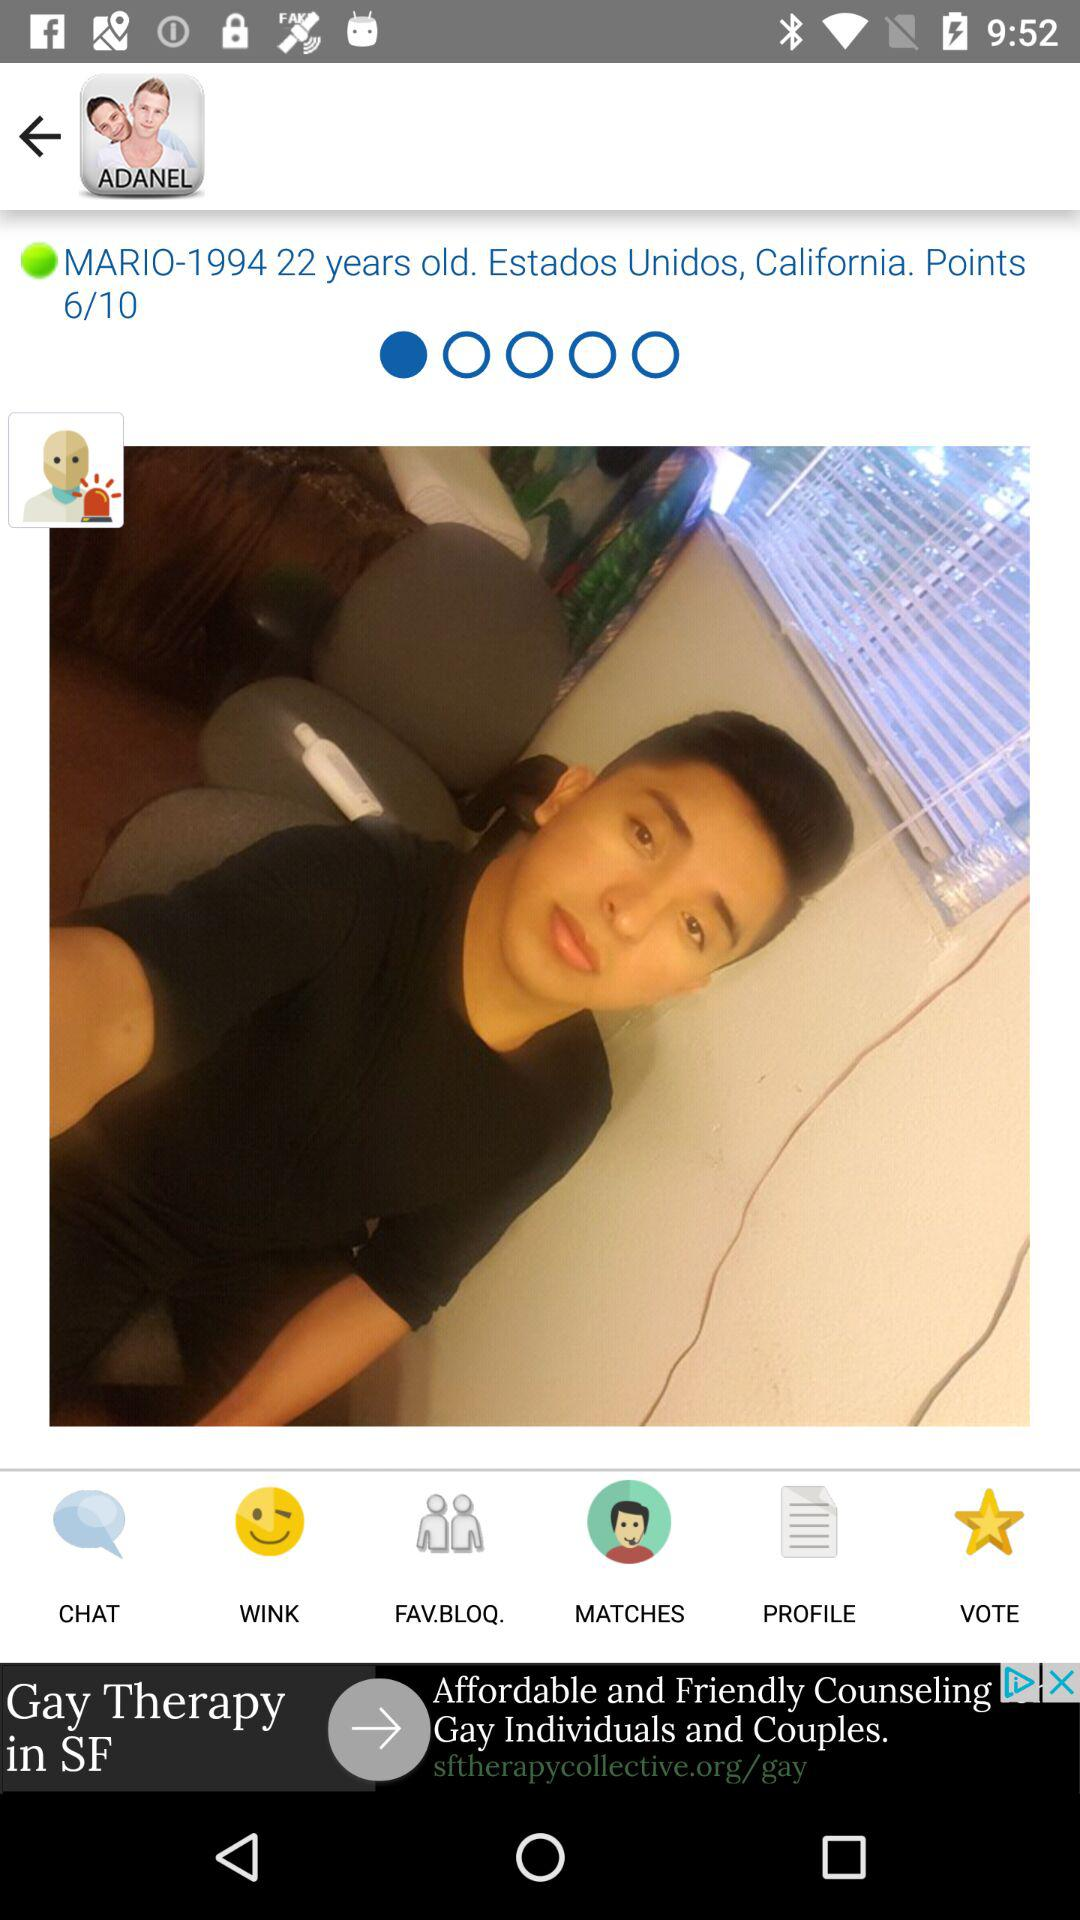What is the age of the user? The user is 22 years old. 